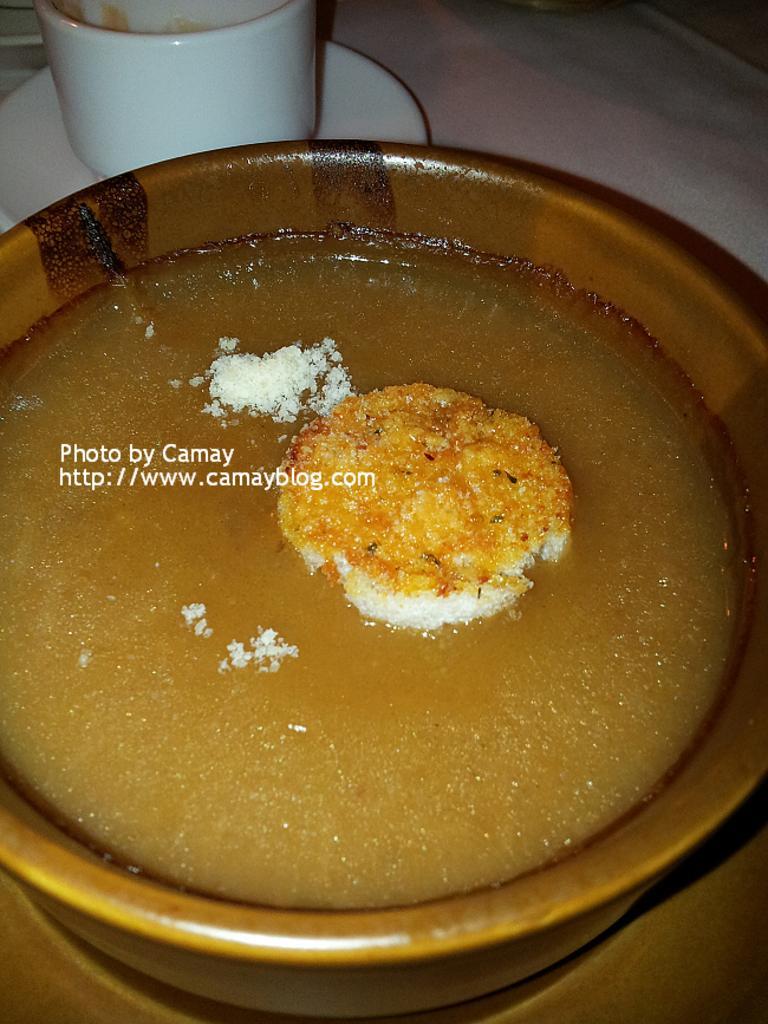How would you summarize this image in a sentence or two? In this image, we can see a table, on the table, we can see a bowl with some food item. In the background, we can see a cup and a plate. 